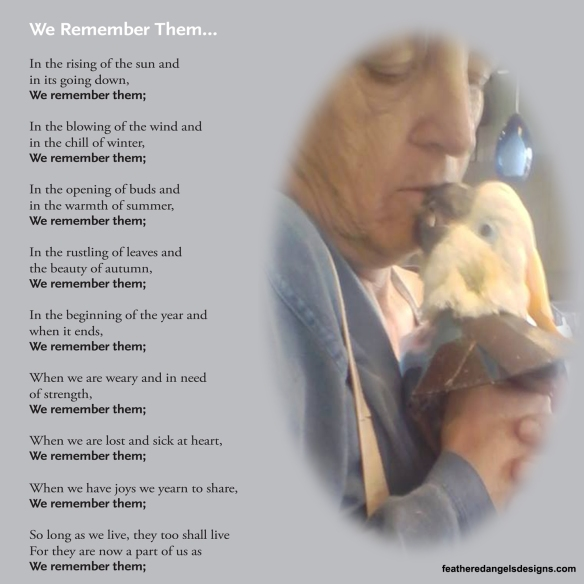If this image were part of a larger story, what role do you think the bird would play in the person's life? If this image were part of a larger story, the bird would likely play the role of a faithful companion and a symbol of unwavering love. The bird could be a significant figure that brought joy, support, and comfort to the person's life, perhaps during times of solitude or hardship. This relationship might be central to the story, highlighting themes of loyalty, emotional support, and the profound connections that can be formed with animals.  Imagine a fantastical scenario related to this image. In a fantastical scenario, the bird could be a mystical creature, a guardian angel in disguise, watching over the person and providing guidance and protection. Perhaps the bird has the ability to communicate telepathically or through dreams, revealing hidden truths and imparting ancient wisdom. In this ethereal realm, the bond between the person and the bird transcends physical interaction, becoming a powerful force that shapes their destinies and unlocks the mysteries of the universe.  Could this image suggest a moment of farewell between the person and the bird? Yes, this image could indeed suggest a moment of farewell between the person and the bird. The tender kiss might symbolize a goodbye, as the person cherishes this final moment with their beloved companion. This farewell could be filled with gratitude, sorrow, and a deep sense of appreciation for the time they shared together, aligning with the poem's theme of remembering and honoring those who have touched our lives.  How does the setting of this image enhance its emotional impact? The close-up setting of this image enhances its emotional impact by focusing on the intimate moment shared between the person and the bird. The soft lighting and gentle touch add a serene and heartfelt atmosphere, drawing the viewer in and emphasizing the quiet, tender nature of the interaction. This setting, coupled with the contemplative tones of the poem, creates a peaceful and reflective mood, allowing the emotions of love, remembrance, and connection to resonate more deeply with the audience. 